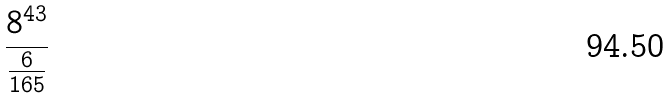Convert formula to latex. <formula><loc_0><loc_0><loc_500><loc_500>\frac { 8 ^ { 4 3 } } { \frac { 6 } { 1 6 5 } }</formula> 